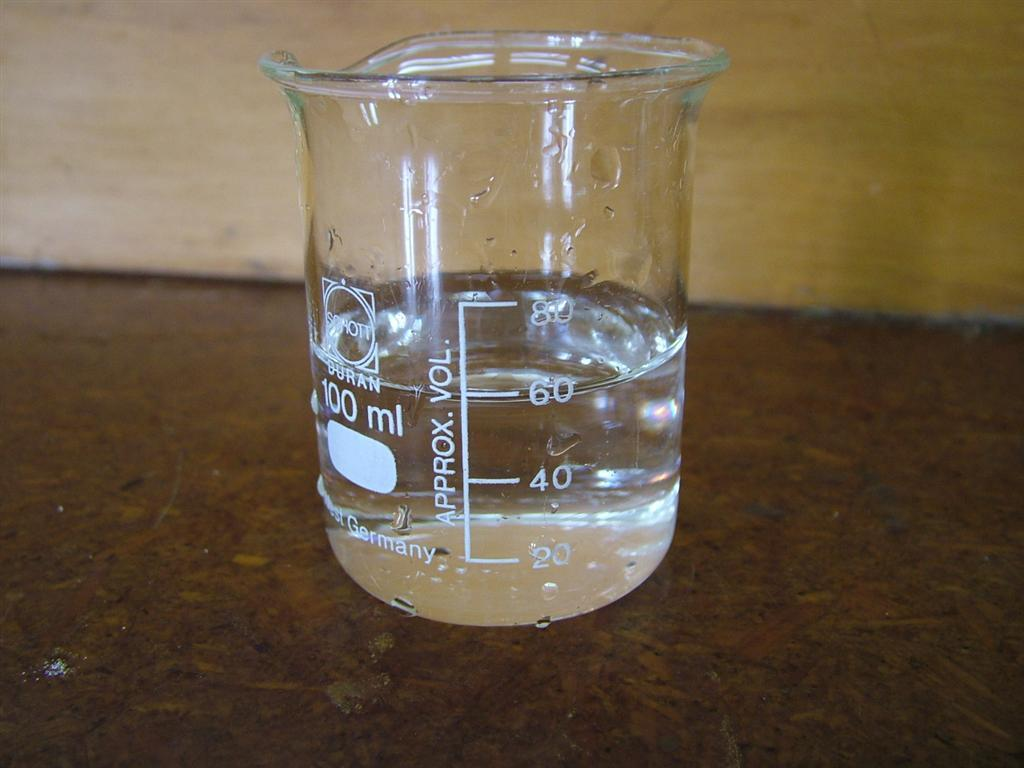Provide a one-sentence caption for the provided image. A beaker is filled with clear liquid up to the 60 line. 